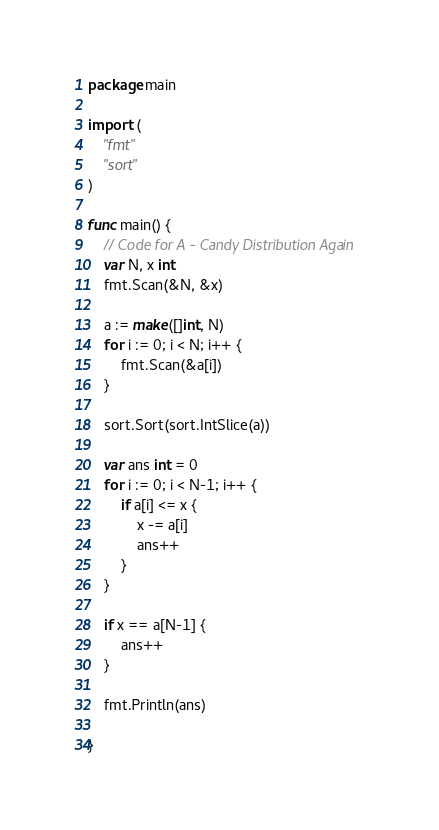<code> <loc_0><loc_0><loc_500><loc_500><_Go_>package main

import (
	"fmt"
	"sort"
)

func main() {
	// Code for A - Candy Distribution Again
	var N, x int
	fmt.Scan(&N, &x)

	a := make([]int, N)
	for i := 0; i < N; i++ {
		fmt.Scan(&a[i])
	}

	sort.Sort(sort.IntSlice(a))

	var ans int = 0
	for i := 0; i < N-1; i++ {
		if a[i] <= x {
			x -= a[i]
			ans++
		}
	}

	if x == a[N-1] {
		ans++
	}

	fmt.Println(ans)

}
</code> 